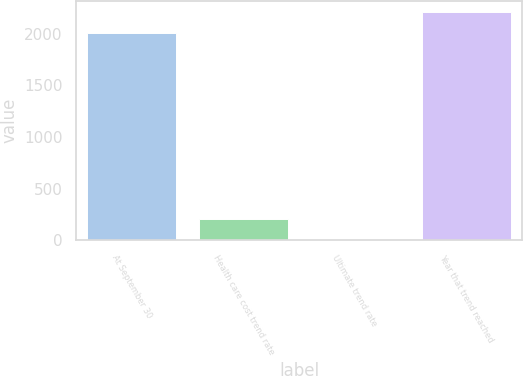<chart> <loc_0><loc_0><loc_500><loc_500><bar_chart><fcel>At September 30<fcel>Health care cost trend rate<fcel>Ultimate trend rate<fcel>Year that trend reached<nl><fcel>2007<fcel>205.8<fcel>5<fcel>2207.8<nl></chart> 